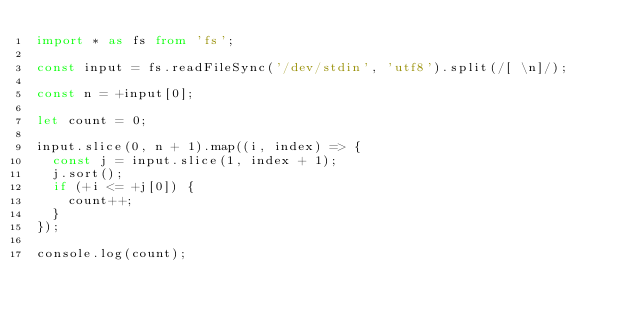Convert code to text. <code><loc_0><loc_0><loc_500><loc_500><_TypeScript_>import * as fs from 'fs';

const input = fs.readFileSync('/dev/stdin', 'utf8').split(/[ \n]/);

const n = +input[0];

let count = 0;

input.slice(0, n + 1).map((i, index) => {
  const j = input.slice(1, index + 1);
  j.sort();
  if (+i <= +j[0]) {
    count++;
  }
});

console.log(count);</code> 